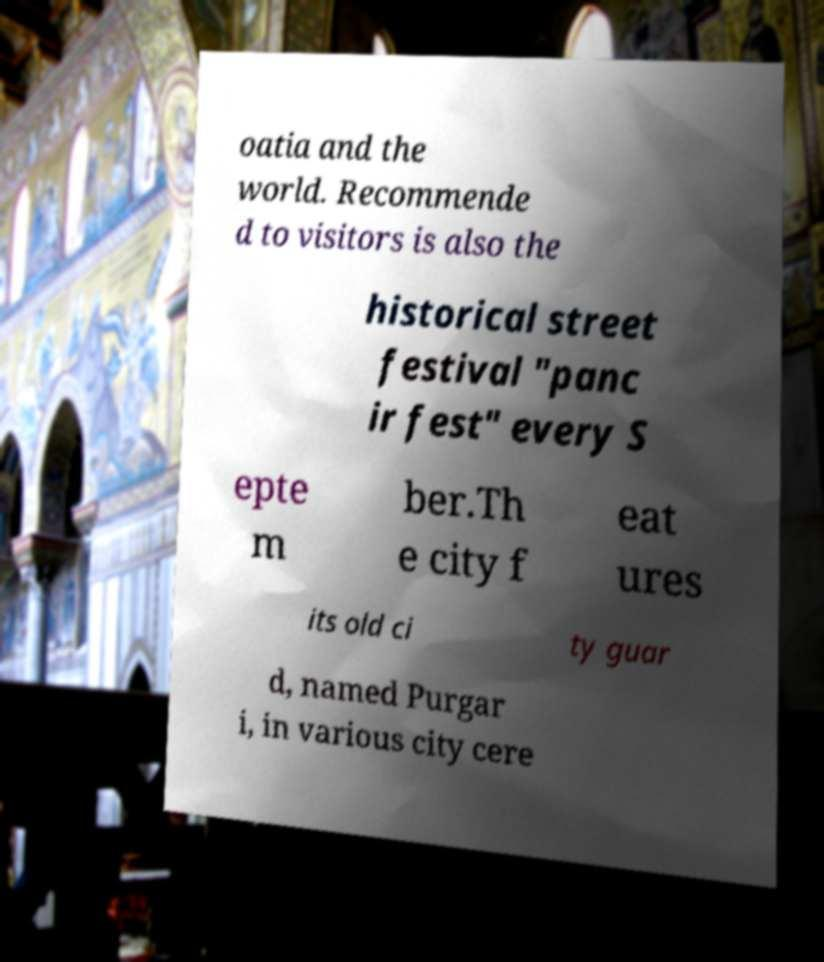Could you extract and type out the text from this image? oatia and the world. Recommende d to visitors is also the historical street festival "panc ir fest" every S epte m ber.Th e city f eat ures its old ci ty guar d, named Purgar i, in various city cere 